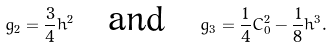Convert formula to latex. <formula><loc_0><loc_0><loc_500><loc_500>g _ { 2 } = \frac { 3 } { 4 } h ^ { 2 } \quad \text {and} \quad g _ { 3 } = \frac { 1 } { 4 } C _ { 0 } ^ { 2 } - \frac { 1 } { 8 } h ^ { 3 } .</formula> 